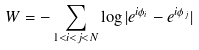<formula> <loc_0><loc_0><loc_500><loc_500>W = - \sum _ { 1 < i < j < N } \log | e ^ { i \phi _ { i } } - e ^ { i \phi _ { j } } |</formula> 